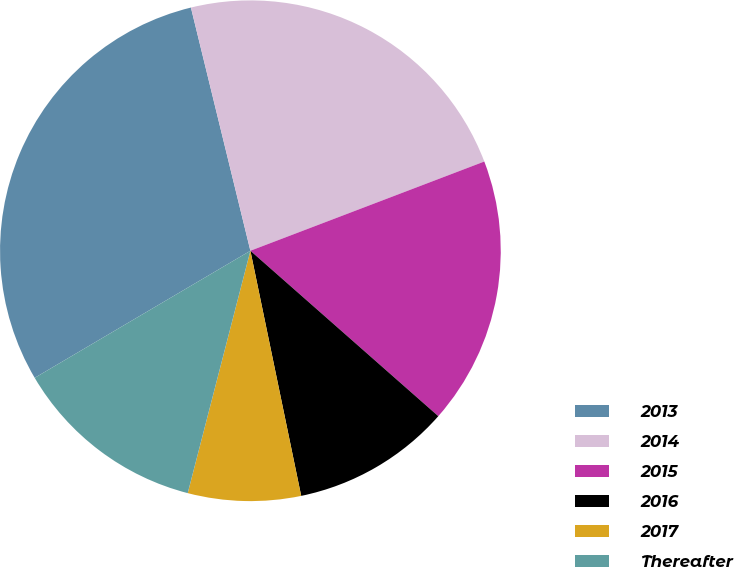<chart> <loc_0><loc_0><loc_500><loc_500><pie_chart><fcel>2013<fcel>2014<fcel>2015<fcel>2016<fcel>2017<fcel>Thereafter<nl><fcel>29.66%<fcel>23.02%<fcel>17.29%<fcel>10.26%<fcel>7.28%<fcel>12.5%<nl></chart> 